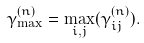Convert formula to latex. <formula><loc_0><loc_0><loc_500><loc_500>\gamma _ { \max } ^ { ( n ) } = \max _ { i , j } ( \gamma _ { i j } ^ { ( n ) } ) .</formula> 